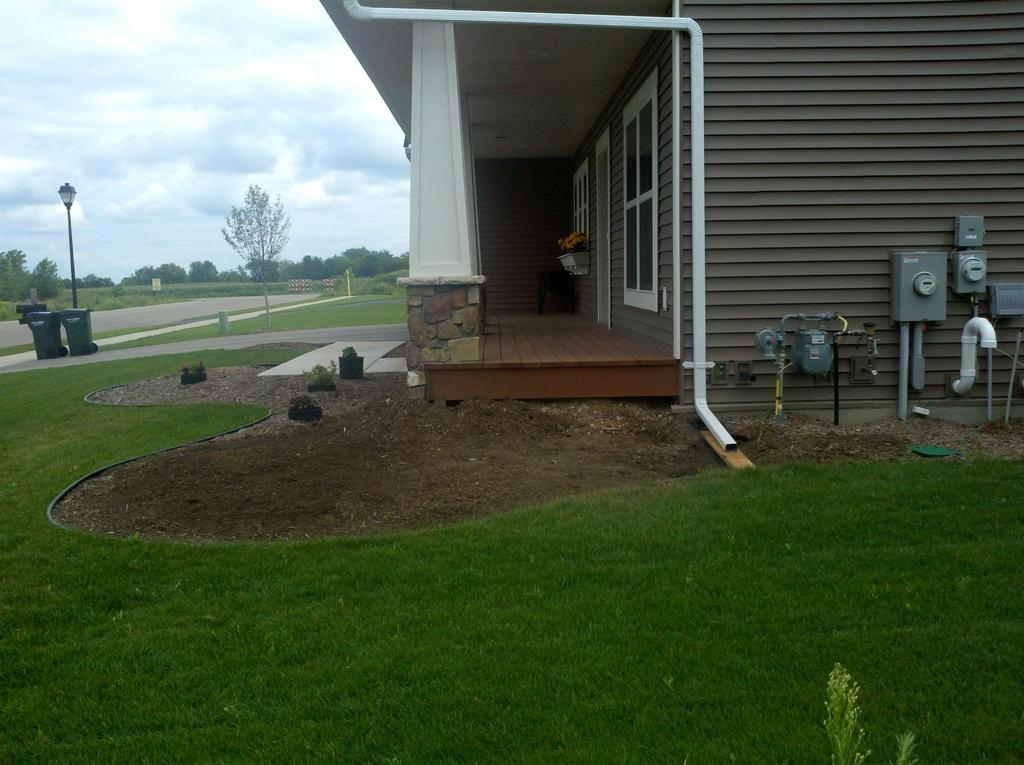What type of vegetation can be seen in the image? There is grass in the image. What objects are present in the image? There are boxes, a machine, a pipe, and dustbins visible in the image. What type of structure is in the image? There is a building in the image. What can be seen in the background of the image? Trees, clouds, and dustbins are visible in the background. What type of bell can be heard ringing in the image? There is no bell present in the image, and therefore no sound can be heard. What type of rake is being used to clean the grass in the image? There is no rake present in the image, and the grass does not appear to be cleaned or maintained in any way. 